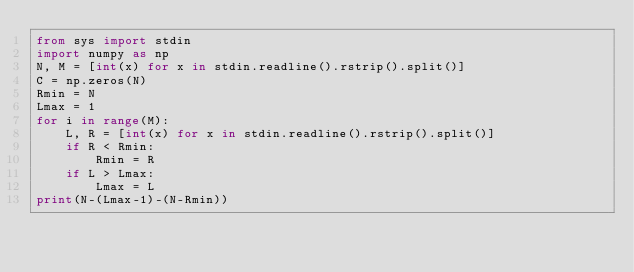<code> <loc_0><loc_0><loc_500><loc_500><_Python_>from sys import stdin
import numpy as np
N, M = [int(x) for x in stdin.readline().rstrip().split()]
C = np.zeros(N)
Rmin = N
Lmax = 1
for i in range(M):
    L, R = [int(x) for x in stdin.readline().rstrip().split()]
    if R < Rmin:
        Rmin = R
    if L > Lmax:
        Lmax = L
print(N-(Lmax-1)-(N-Rmin))</code> 